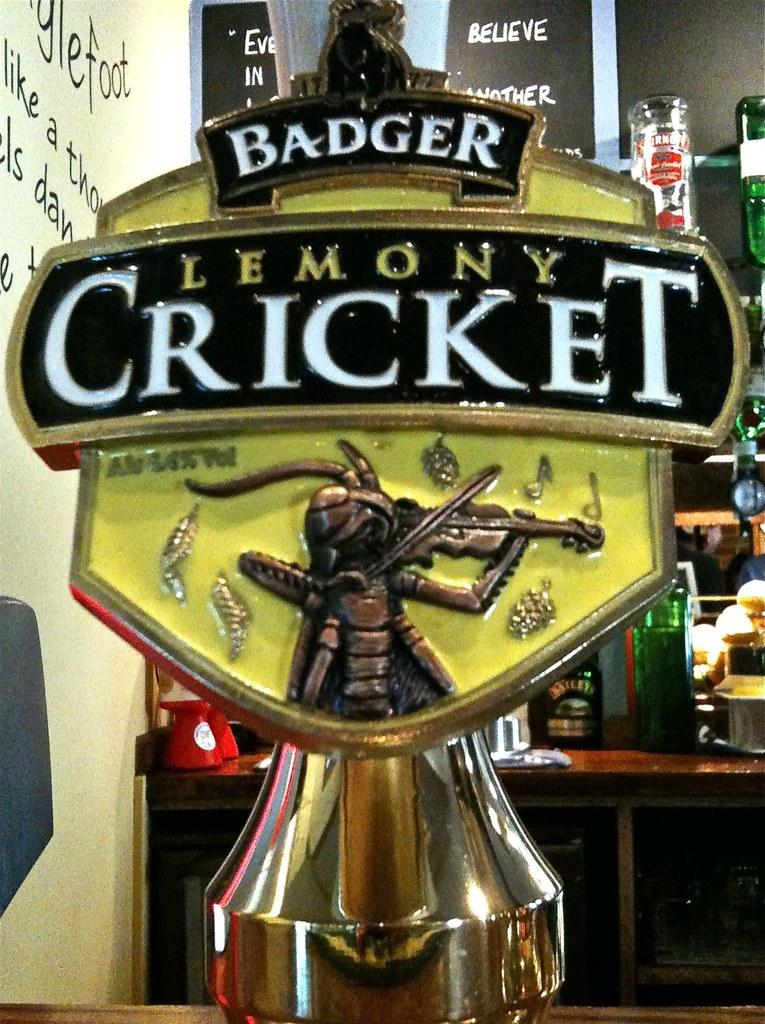<image>
Offer a succinct explanation of the picture presented. Lemony Cricket beer tap from Badger showing a bug playing a violin. 